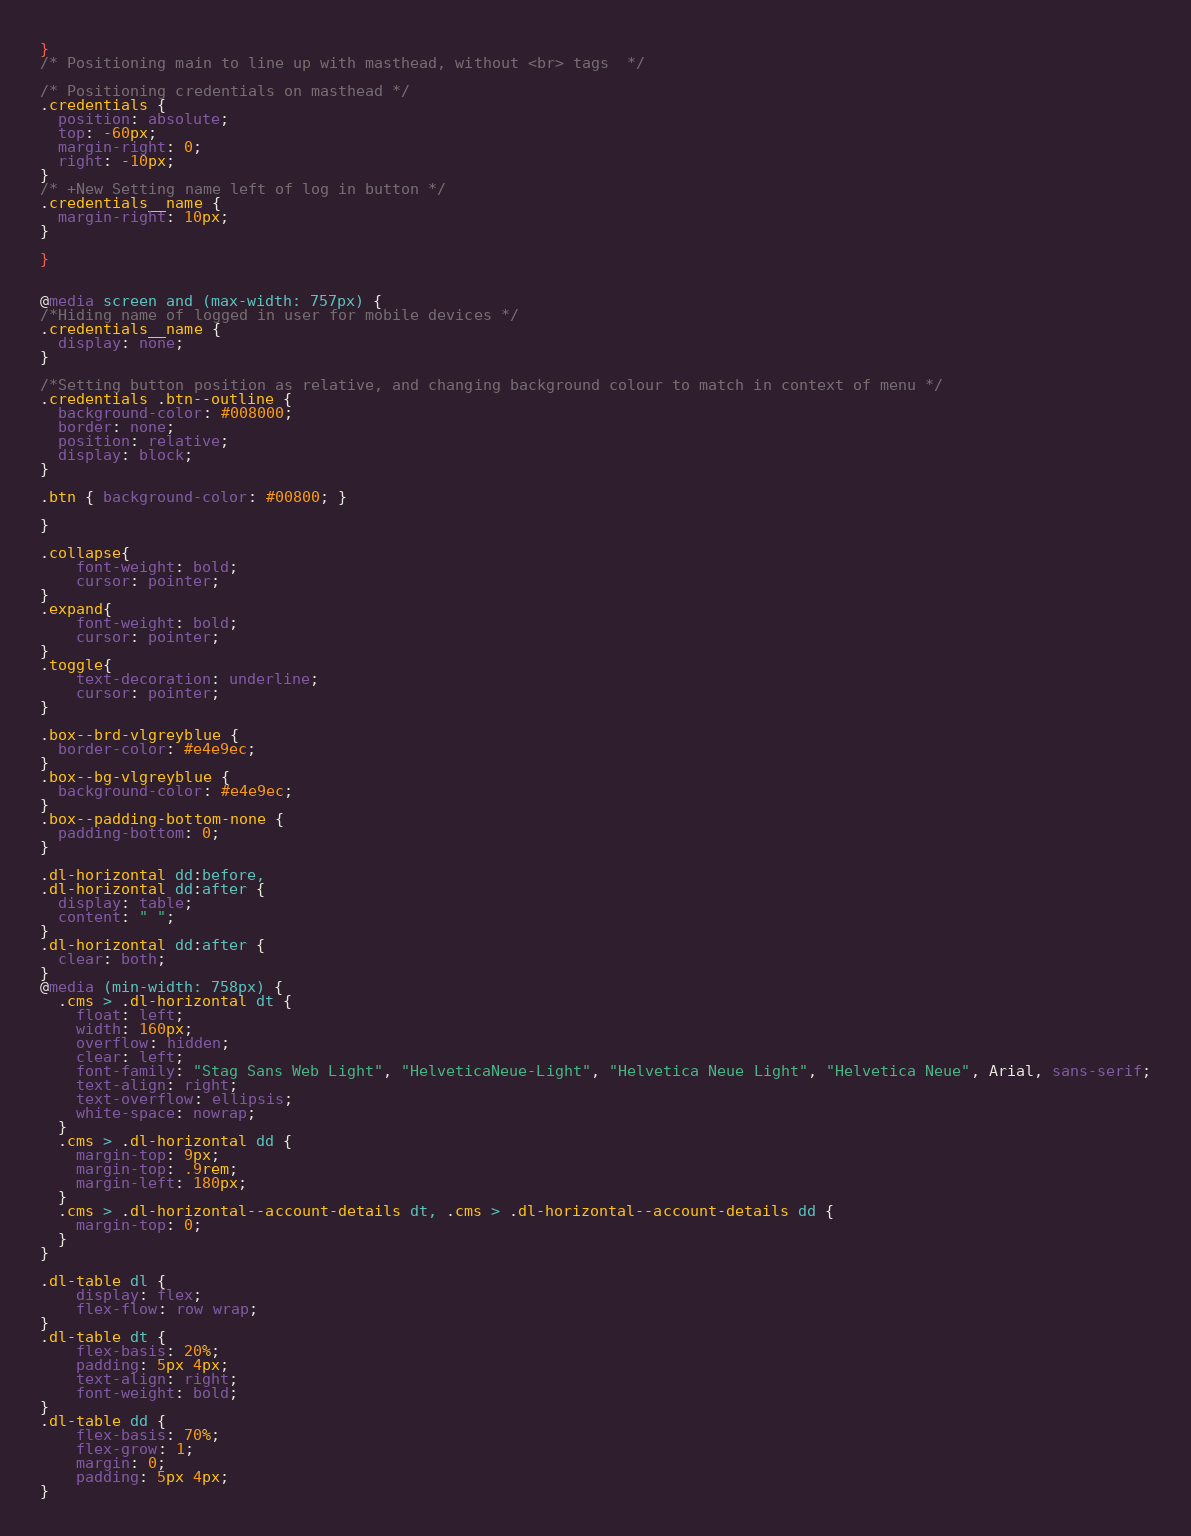Convert code to text. <code><loc_0><loc_0><loc_500><loc_500><_CSS_>}
/* Positioning main to line up with masthead, without <br> tags  */

/* Positioning credentials on masthead */
.credentials {
  position: absolute;
  top: -60px;
  margin-right: 0;
  right: -10px;
}
/* +New Setting name left of log in button */
.credentials__name {
  margin-right: 10px;
}

}


@media screen and (max-width: 757px) {
/*Hiding name of logged in user for mobile devices */
.credentials__name {
  display: none;
}

/*Setting button position as relative, and changing background colour to match in context of menu */
.credentials .btn--outline {
  background-color: #008000;
  border: none;
  position: relative;
  display: block;
}

.btn { background-color: #00800; }

}

.collapse{
	font-weight: bold;
	cursor: pointer;
}
.expand{
	font-weight: bold;
	cursor: pointer;
}
.toggle{
	text-decoration: underline;
	cursor: pointer;
}

.box--brd-vlgreyblue {
  border-color: #e4e9ec;
}
.box--bg-vlgreyblue {
  background-color: #e4e9ec;
}
.box--padding-bottom-none {
  padding-bottom: 0;
}

.dl-horizontal dd:before,
.dl-horizontal dd:after {
  display: table;
  content: " ";
}
.dl-horizontal dd:after {
  clear: both;
}
@media (min-width: 758px) {
  .cms > .dl-horizontal dt {
    float: left;
    width: 160px;
    overflow: hidden;
    clear: left;
    font-family: "Stag Sans Web Light", "HelveticaNeue-Light", "Helvetica Neue Light", "Helvetica Neue", Arial, sans-serif;
    text-align: right;
    text-overflow: ellipsis;
    white-space: nowrap;
  }
  .cms > .dl-horizontal dd {
    margin-top: 9px;
    margin-top: .9rem;
    margin-left: 180px;
  }
  .cms > .dl-horizontal--account-details dt, .cms > .dl-horizontal--account-details dd {
    margin-top: 0;
  }
}

.dl-table dl {
    display: flex;
    flex-flow: row wrap;
}
.dl-table dt {
    flex-basis: 20%;
    padding: 5px 4px;
    text-align: right;
    font-weight: bold;
}
.dl-table dd {
    flex-basis: 70%;
    flex-grow: 1;
    margin: 0;
    padding: 5px 4px;
}</code> 